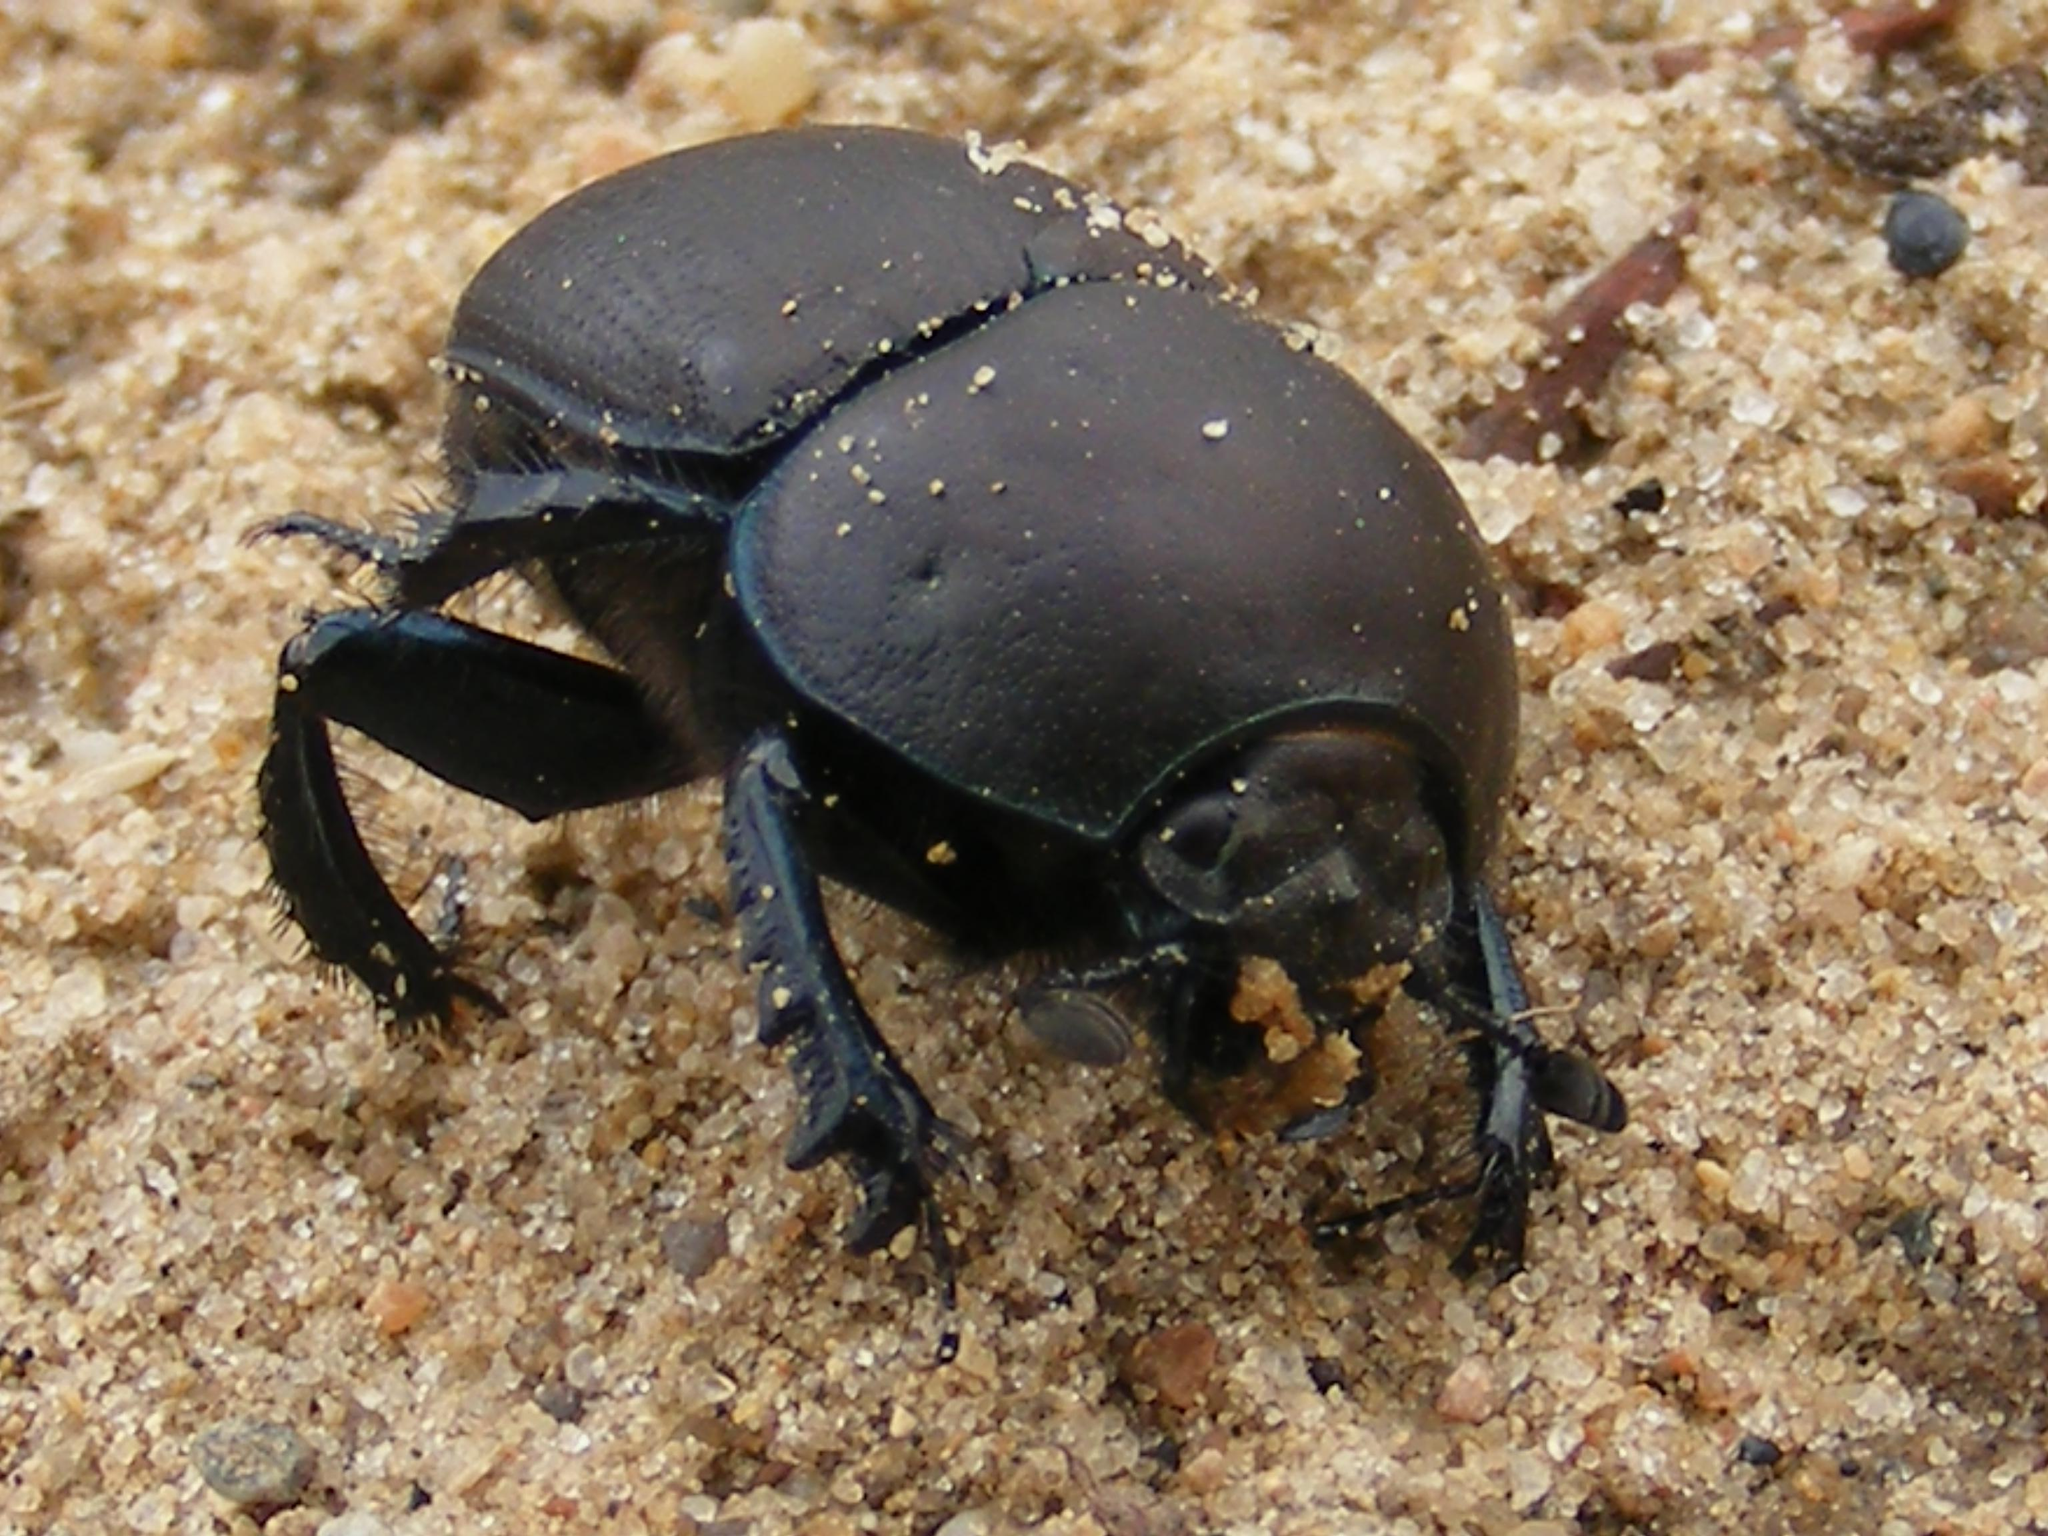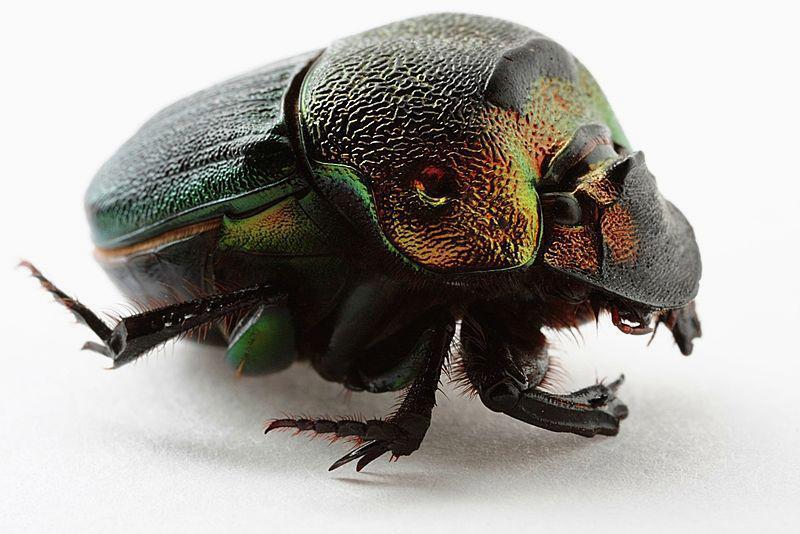The first image is the image on the left, the second image is the image on the right. Given the left and right images, does the statement "At least one image shows a beetle with a large horn." hold true? Answer yes or no. No. 